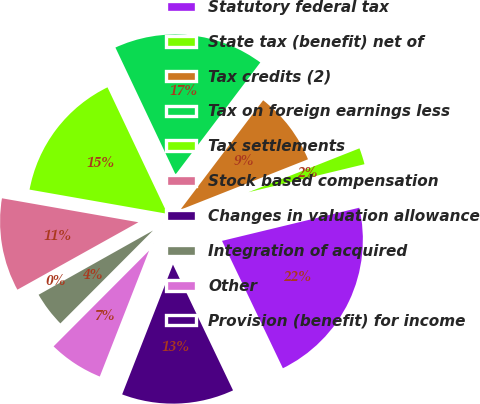Convert chart. <chart><loc_0><loc_0><loc_500><loc_500><pie_chart><fcel>Statutory federal tax<fcel>State tax (benefit) net of<fcel>Tax credits (2)<fcel>Tax on foreign earnings less<fcel>Tax settlements<fcel>Stock based compensation<fcel>Changes in valuation allowance<fcel>Integration of acquired<fcel>Other<fcel>Provision (benefit) for income<nl><fcel>21.68%<fcel>2.22%<fcel>8.7%<fcel>17.35%<fcel>15.19%<fcel>10.86%<fcel>0.05%<fcel>4.38%<fcel>6.54%<fcel>13.03%<nl></chart> 